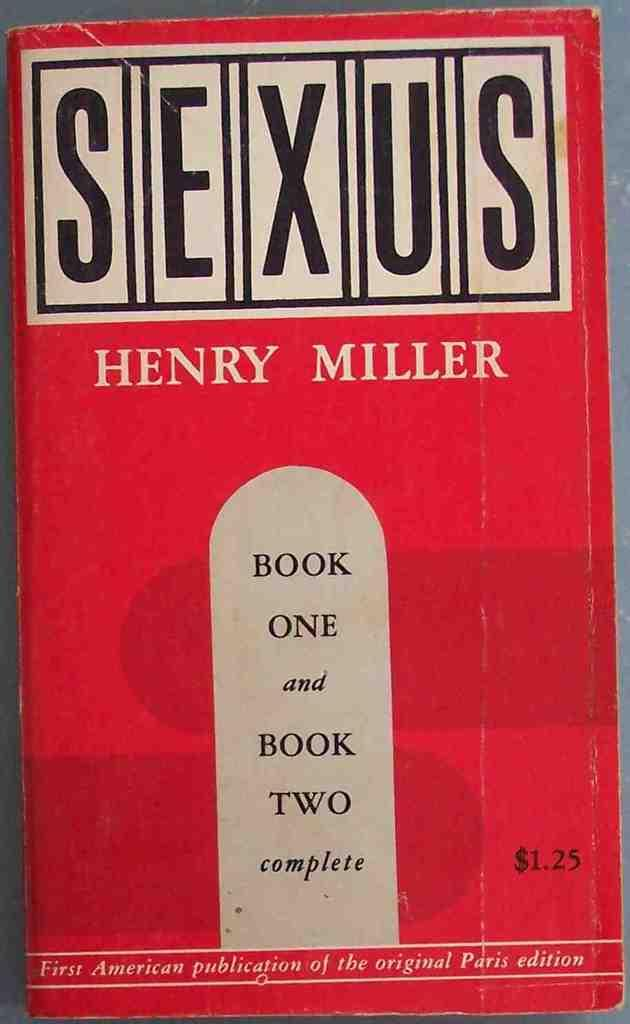What object can be seen in the image? There is a book in the image. What is visible on the book? There is text written on the book. What type of coat is being worn by the book in the image? There is no coat present in the image, as the main subject is a book, which does not wear clothing. 